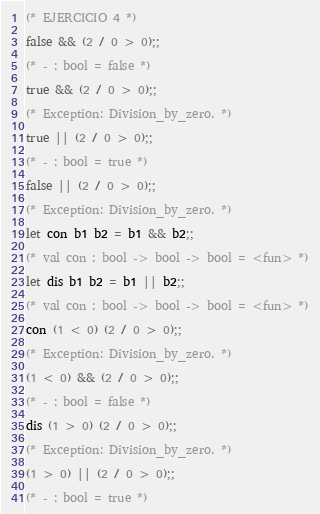<code> <loc_0><loc_0><loc_500><loc_500><_OCaml_>(* EJERCICIO 4 *)

false && (2 / 0 > 0);;

(* - : bool = false *)

true && (2 / 0 > 0);;

(* Exception: Division_by_zero. *)

true || (2 / 0 > 0);;

(* - : bool = true *)

false || (2 / 0 > 0);;

(* Exception: Division_by_zero. *)

let con b1 b2 = b1 && b2;;

(* val con : bool -> bool -> bool = <fun> *)

let dis b1 b2 = b1 || b2;;

(* val con : bool -> bool -> bool = <fun> *)

con (1 < 0) (2 / 0 > 0);;

(* Exception: Division_by_zero. *)

(1 < 0) && (2 / 0 > 0);;

(* - : bool = false *)

dis (1 > 0) (2 / 0 > 0);;

(* Exception: Division_by_zero. *)

(1 > 0) || (2 / 0 > 0);;

(* - : bool = true *)
</code> 